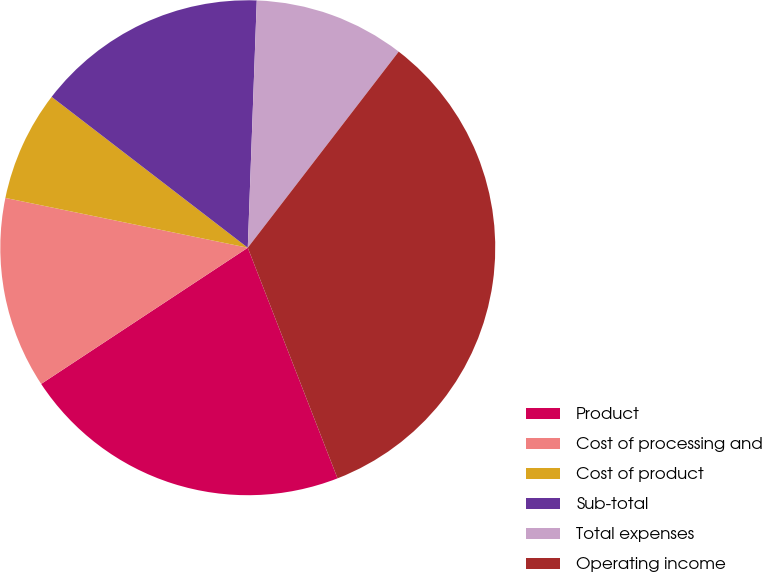Convert chart. <chart><loc_0><loc_0><loc_500><loc_500><pie_chart><fcel>Product<fcel>Cost of processing and<fcel>Cost of product<fcel>Sub-total<fcel>Total expenses<fcel>Operating income<nl><fcel>21.63%<fcel>12.5%<fcel>7.21%<fcel>15.14%<fcel>9.86%<fcel>33.65%<nl></chart> 